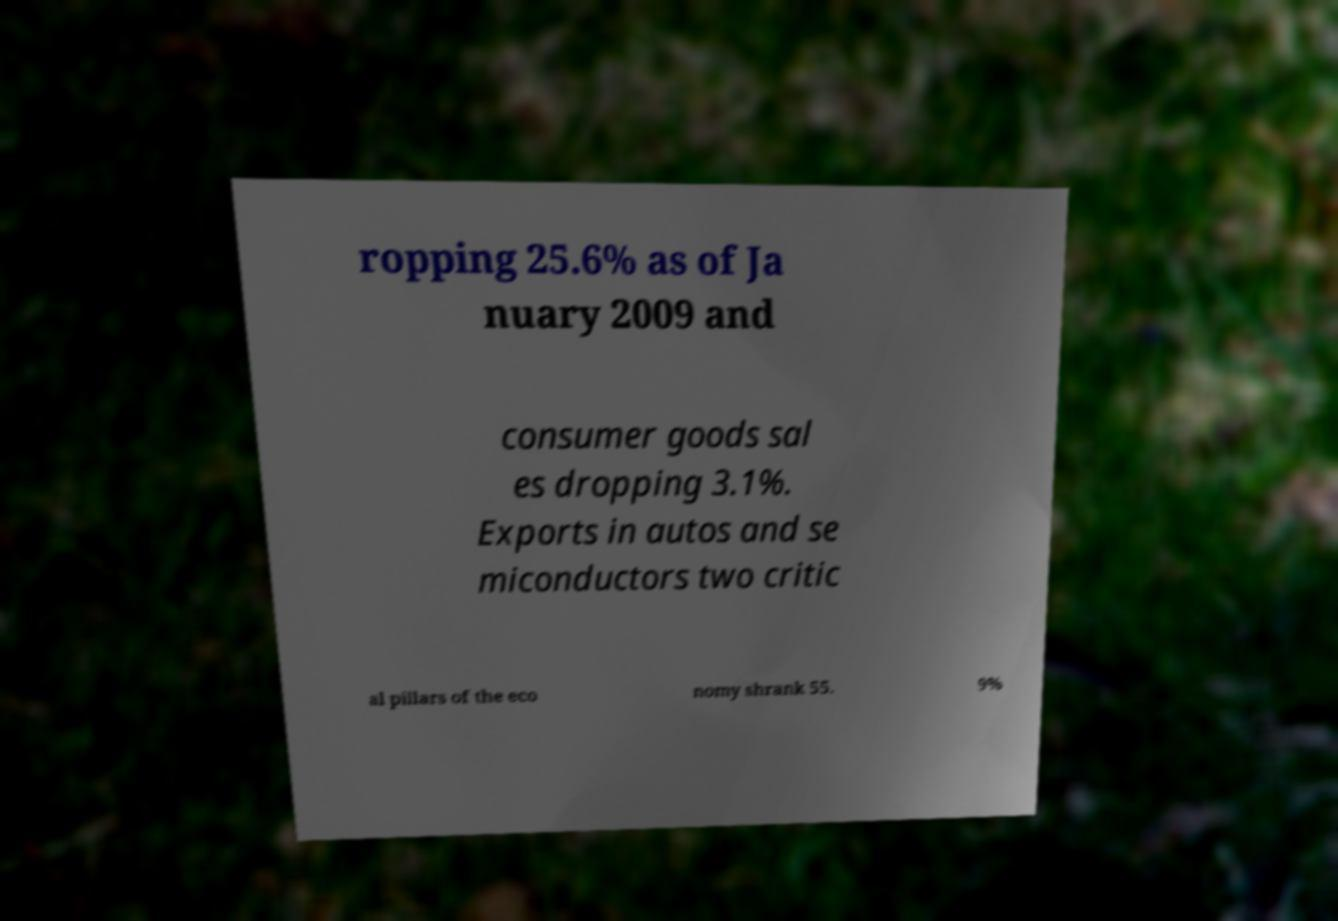Please identify and transcribe the text found in this image. ropping 25.6% as of Ja nuary 2009 and consumer goods sal es dropping 3.1%. Exports in autos and se miconductors two critic al pillars of the eco nomy shrank 55. 9% 